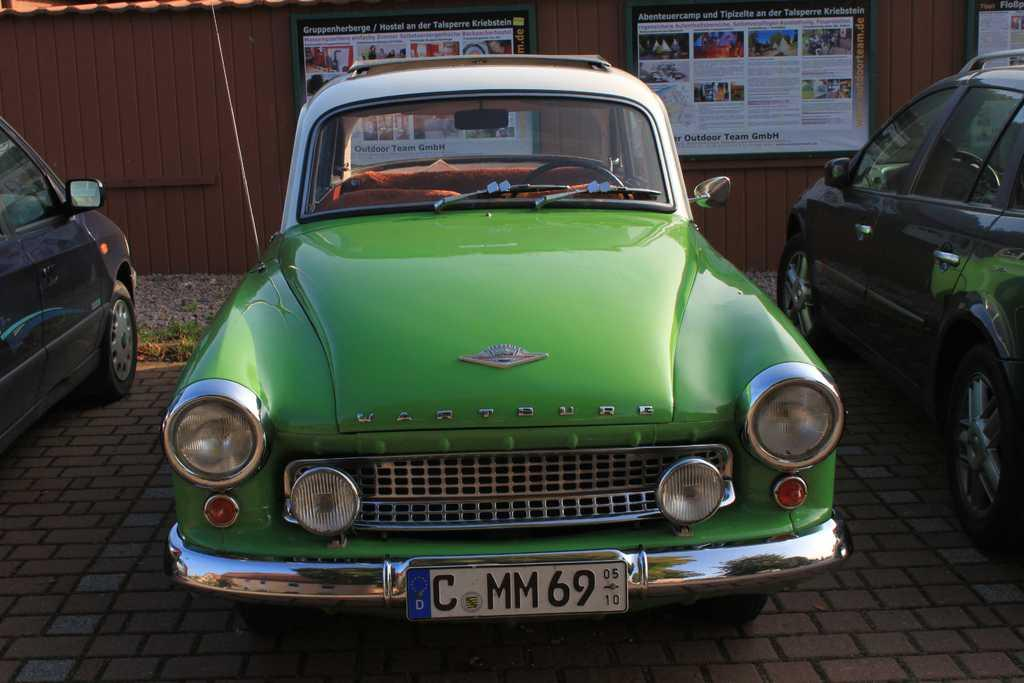How many vehicles can be seen in the image? There are three vehicles parked in the image. What is the location of the vehicles in the image? The vehicles are parked in the image. What can be seen in the background of the image? There are boards attached to a wall in the background of the image. Can you see a kite flying in the image? There is no kite visible in the image. 